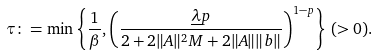Convert formula to latex. <formula><loc_0><loc_0><loc_500><loc_500>\tau \colon = \min \left \{ \frac { 1 } { \beta } , \left ( \frac { \underline { \lambda } p } { 2 + 2 \| A \| ^ { 2 } M + 2 \| A \| \| b \| } \right ) ^ { 1 - p } \right \} \, ( > 0 ) .</formula> 